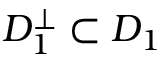Convert formula to latex. <formula><loc_0><loc_0><loc_500><loc_500>D _ { 1 } ^ { \bot } \subset D _ { 1 }</formula> 